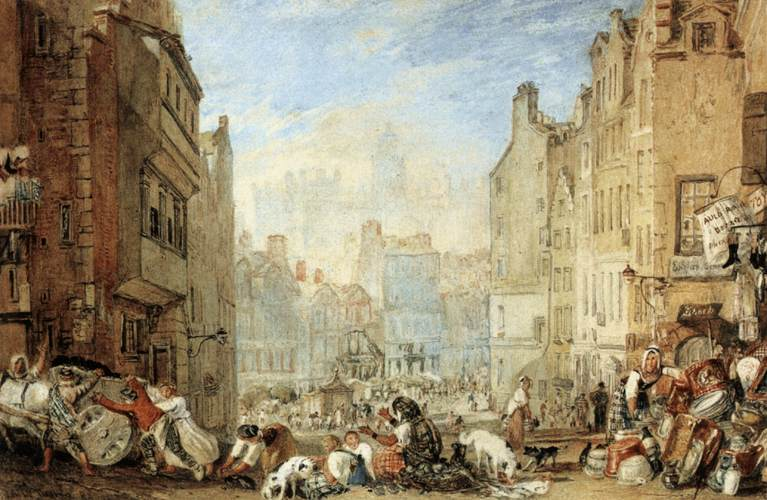Describe a realistic scenario that one of the people in the painting might be experiencing. A street vendor named Marie has set up her stall early in the morning, displaying an array of fresh produce. Throughout the day, she interacts with regular customers, offering friendly conversation along with her goods. As a trusted member of the community, she knows many of the locals by name and has a keen sense for bartering, ensuring she can support her family. By noon, her two young children arrive from a nearby school, adding playful energy to her stall until evening when they all head home together. 